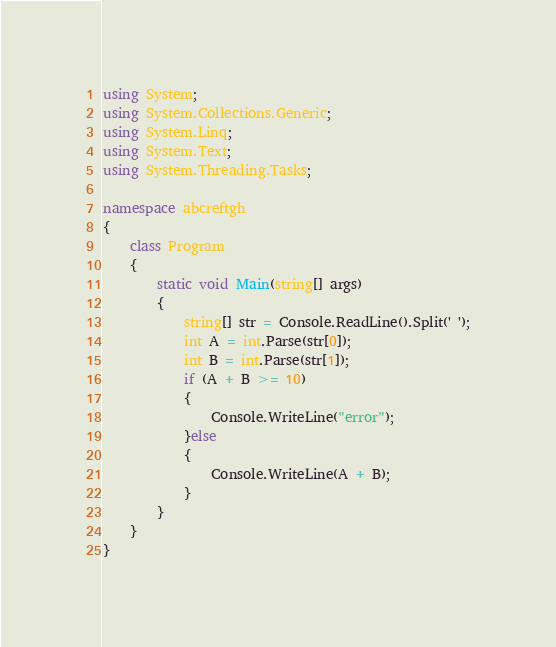Convert code to text. <code><loc_0><loc_0><loc_500><loc_500><_C#_>using System;
using System.Collections.Generic;
using System.Linq;
using System.Text;
using System.Threading.Tasks;

namespace abcreftgh
{
    class Program
    {
        static void Main(string[] args)
        {
            string[] str = Console.ReadLine().Split(' ');
            int A = int.Parse(str[0]);
            int B = int.Parse(str[1]);
            if (A + B >= 10)
            {
                Console.WriteLine("error");
            }else
            {
                Console.WriteLine(A + B);
            }
        }
    }
}
</code> 